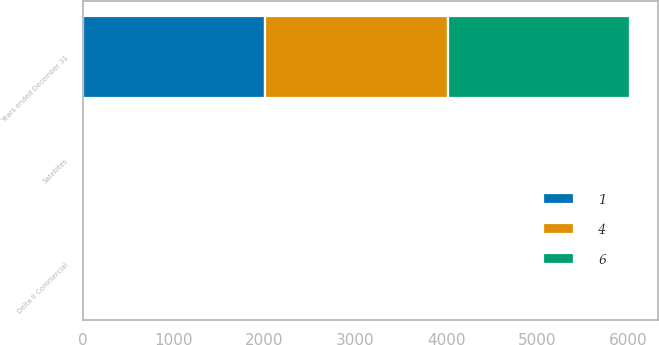Convert chart. <chart><loc_0><loc_0><loc_500><loc_500><stacked_bar_chart><ecel><fcel>Years ended December 31<fcel>Delta II Commercial<fcel>Satellites<nl><fcel>1<fcel>2009<fcel>1<fcel>6<nl><fcel>6<fcel>2008<fcel>2<fcel>1<nl><fcel>4<fcel>2007<fcel>3<fcel>4<nl></chart> 